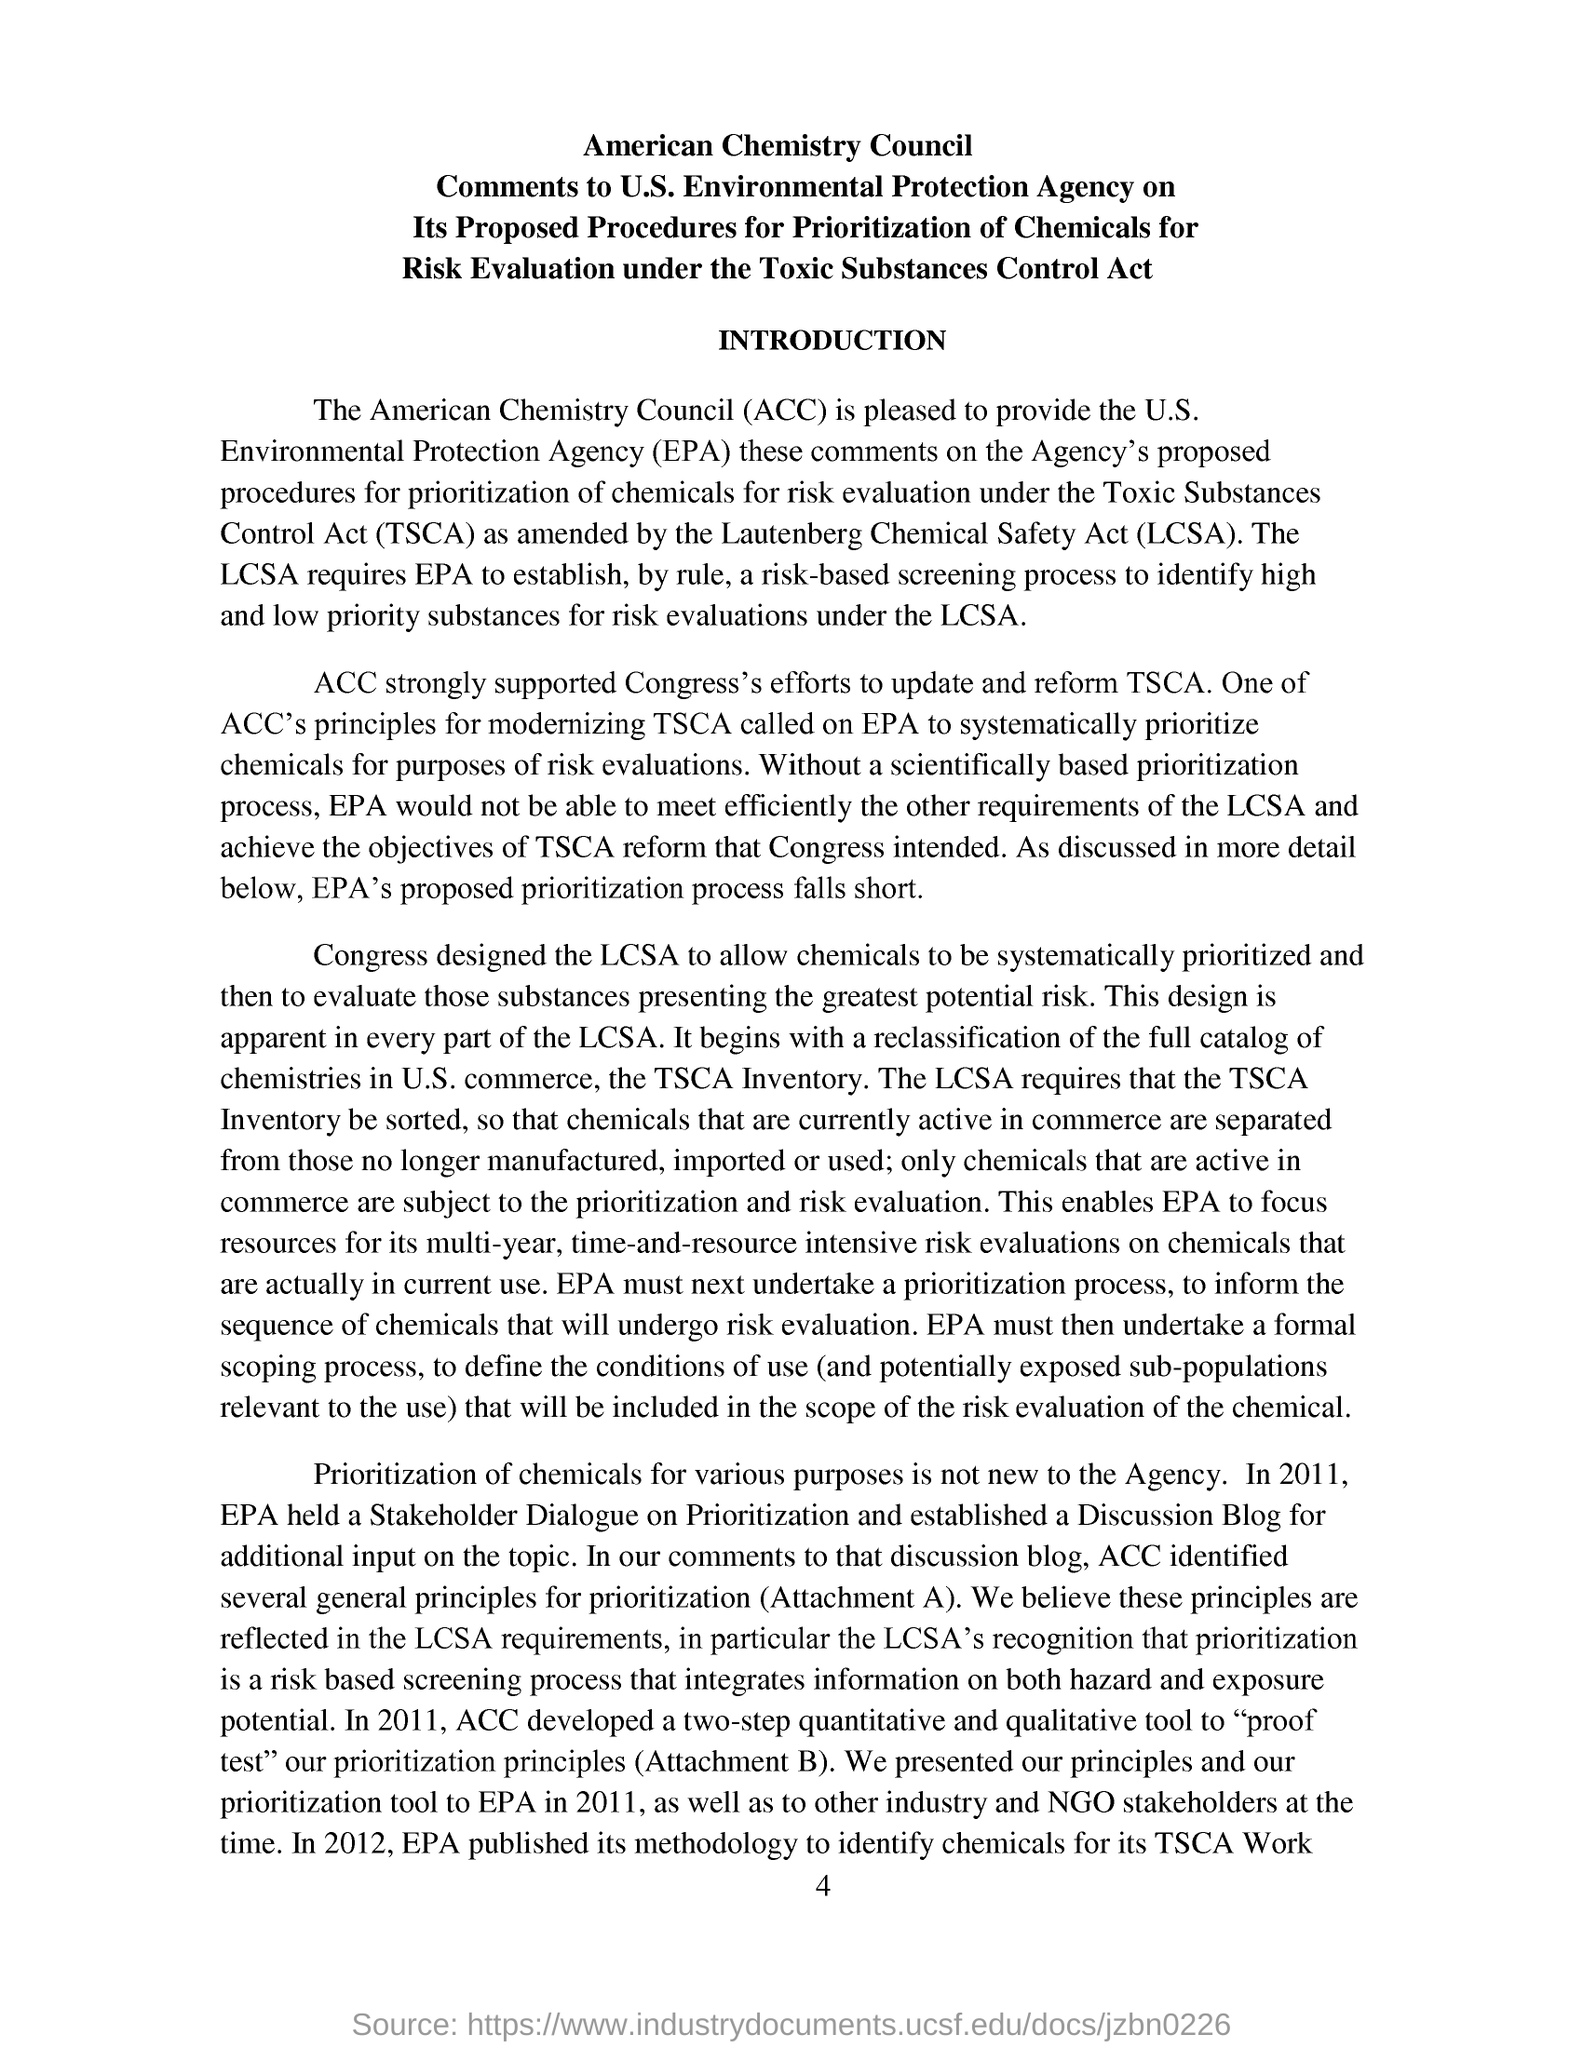What is the abbreviation of Toxic Substances Control Act? The abbreviation of Toxic Substances Control Act is TSCA. This act is a United States law, passed by Congress in 1976, which regulates the introduction of new or already existing chemicals. TSCA gives the EPA the authority to require reporting, record-keeping and testing requirements, and restrictions relating to chemical substances and/or mixtures. 